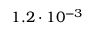Convert formula to latex. <formula><loc_0><loc_0><loc_500><loc_500>1 . 2 \cdot 1 0 ^ { - 3 }</formula> 